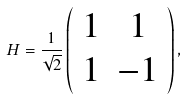Convert formula to latex. <formula><loc_0><loc_0><loc_500><loc_500>H = \frac { 1 } { \sqrt { 2 } } \left ( \begin{array} { c c } 1 & 1 \\ 1 & - 1 \\ \end{array} \right ) ,</formula> 